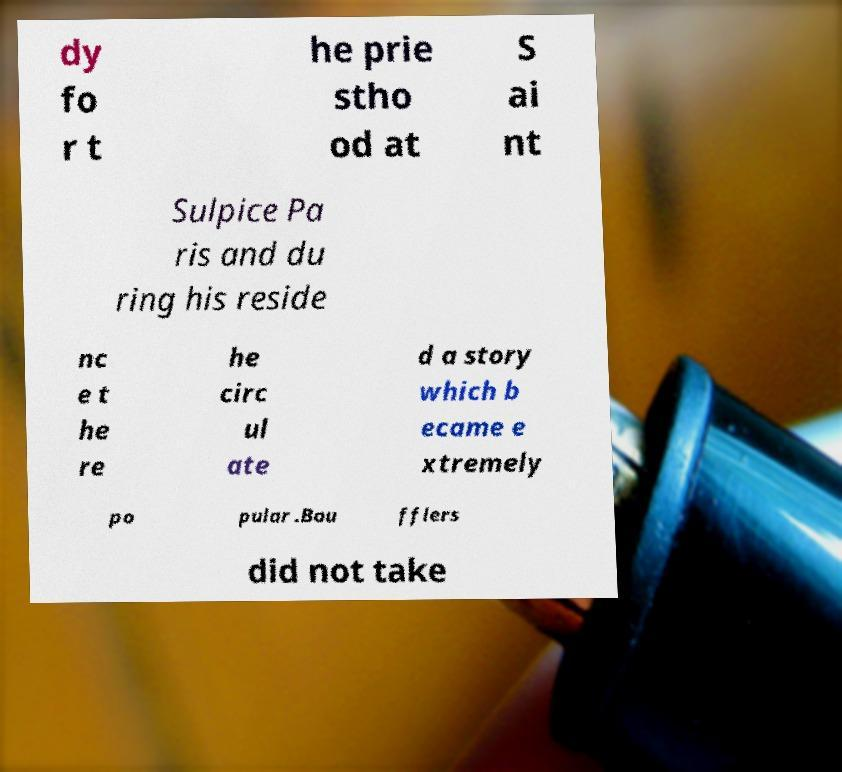What messages or text are displayed in this image? I need them in a readable, typed format. dy fo r t he prie stho od at S ai nt Sulpice Pa ris and du ring his reside nc e t he re he circ ul ate d a story which b ecame e xtremely po pular .Bou fflers did not take 